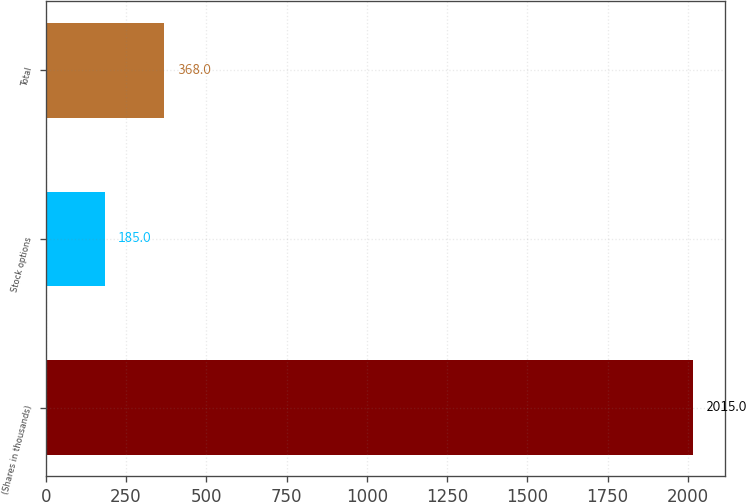<chart> <loc_0><loc_0><loc_500><loc_500><bar_chart><fcel>(Shares in thousands)<fcel>Stock options<fcel>Total<nl><fcel>2015<fcel>185<fcel>368<nl></chart> 